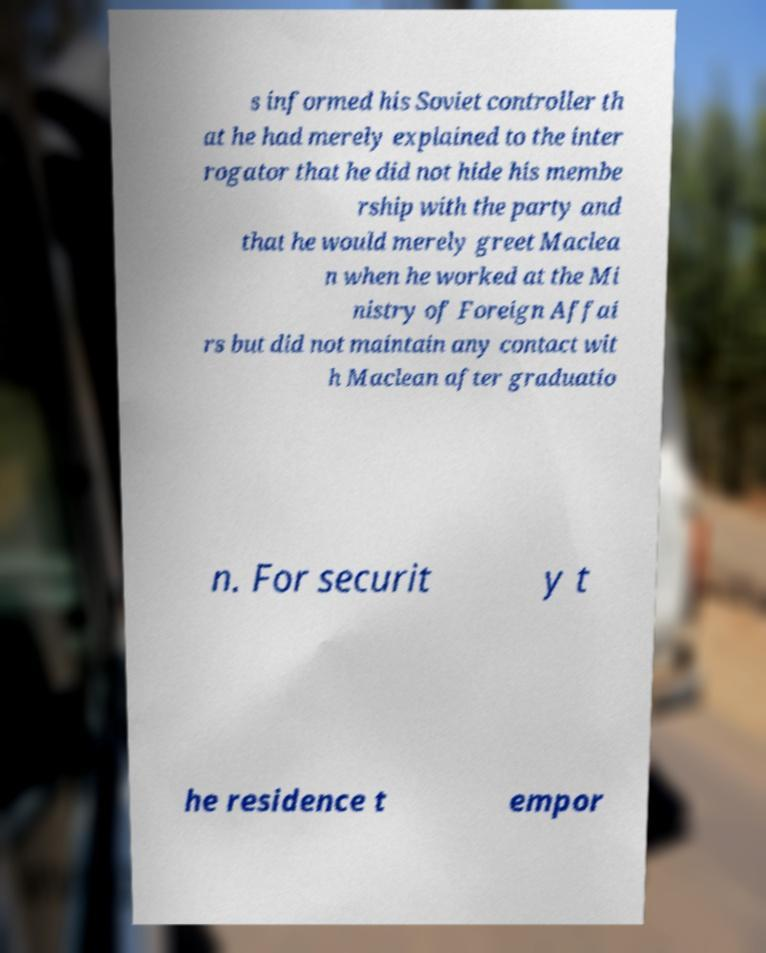Can you accurately transcribe the text from the provided image for me? s informed his Soviet controller th at he had merely explained to the inter rogator that he did not hide his membe rship with the party and that he would merely greet Maclea n when he worked at the Mi nistry of Foreign Affai rs but did not maintain any contact wit h Maclean after graduatio n. For securit y t he residence t empor 